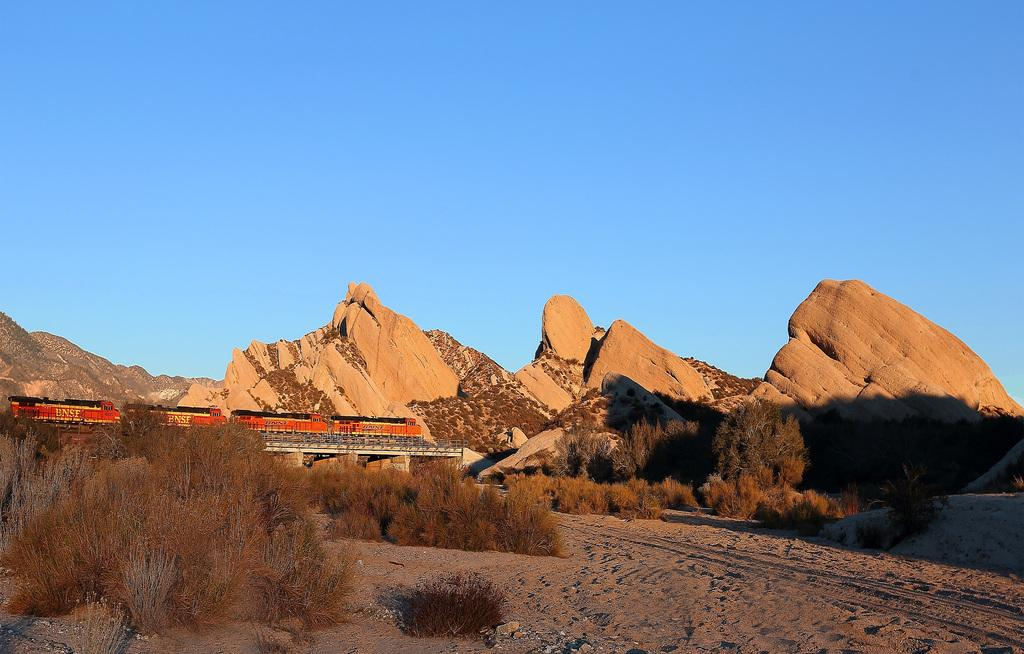What is the main subject of the image? The main subject of the image is a train. Where is the train located in the image? The train is on the left side of the image. What is the train's location in relation to the bridge? The train is on a bridge in the image. What type of natural features can be seen in the image? There are cliffs and plants visible in the image. What type of breakfast is being served in the image? There is no breakfast present in the image; it features a train on a bridge with cliffs and plants. 